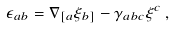<formula> <loc_0><loc_0><loc_500><loc_500>\epsilon _ { a b } = \nabla _ { [ a } \xi _ { b ] } - \gamma _ { a b c } \xi ^ { c } \, ,</formula> 